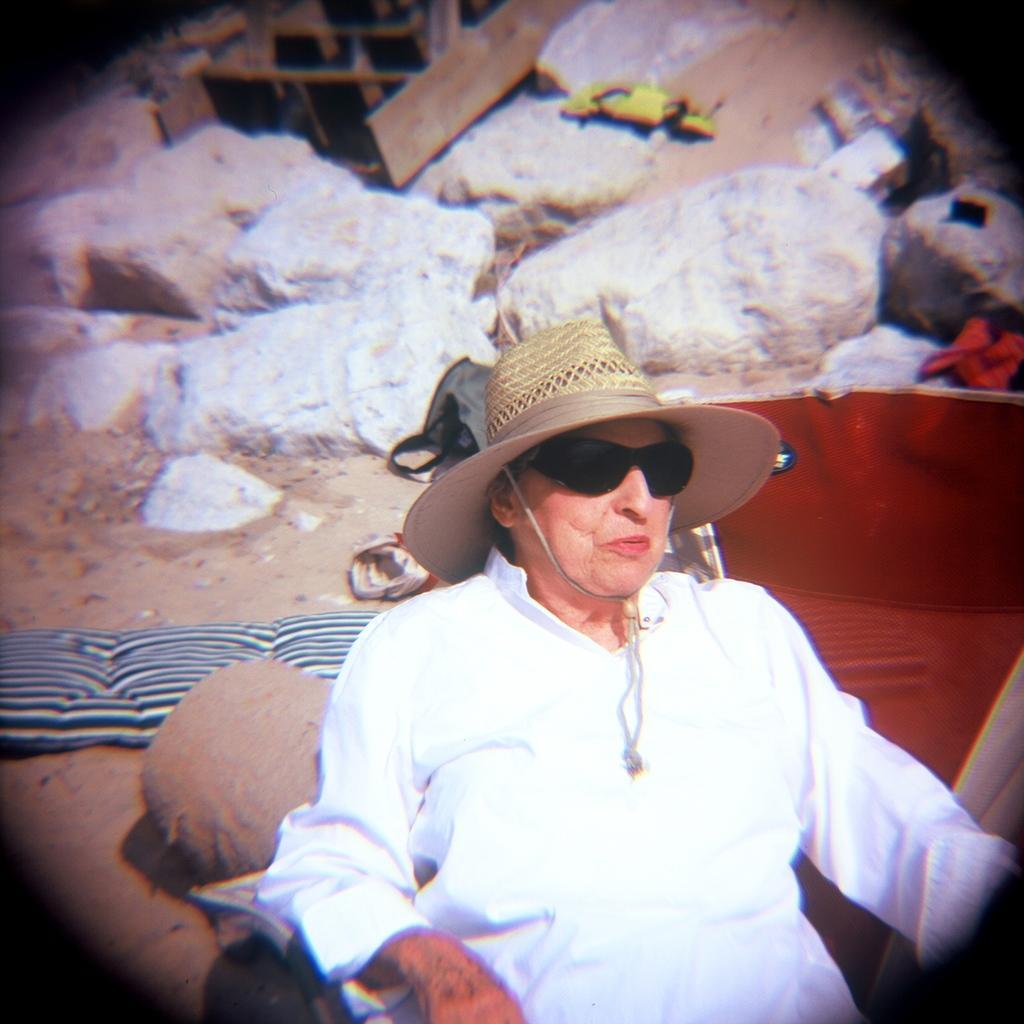In one or two sentences, can you explain what this image depicts? On the right side, there is a person in white color dress, wearing sunglasses and a cap and sitting. In the background, there rocks and a wooden item on the sand surface. 